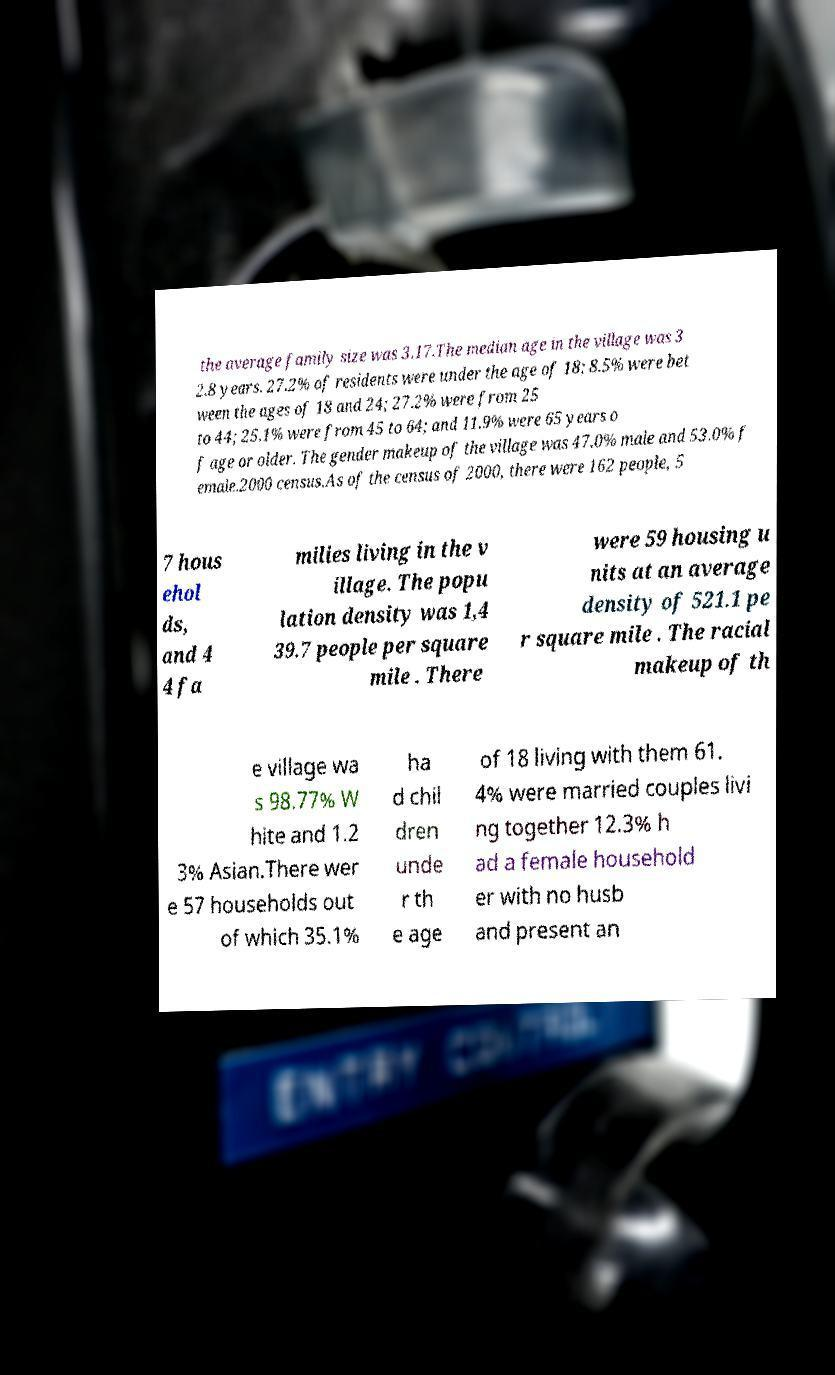Could you extract and type out the text from this image? the average family size was 3.17.The median age in the village was 3 2.8 years. 27.2% of residents were under the age of 18; 8.5% were bet ween the ages of 18 and 24; 27.2% were from 25 to 44; 25.1% were from 45 to 64; and 11.9% were 65 years o f age or older. The gender makeup of the village was 47.0% male and 53.0% f emale.2000 census.As of the census of 2000, there were 162 people, 5 7 hous ehol ds, and 4 4 fa milies living in the v illage. The popu lation density was 1,4 39.7 people per square mile . There were 59 housing u nits at an average density of 521.1 pe r square mile . The racial makeup of th e village wa s 98.77% W hite and 1.2 3% Asian.There wer e 57 households out of which 35.1% ha d chil dren unde r th e age of 18 living with them 61. 4% were married couples livi ng together 12.3% h ad a female household er with no husb and present an 